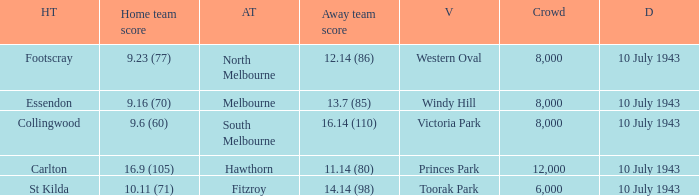When the Home team of carlton played, what was their score? 16.9 (105). 